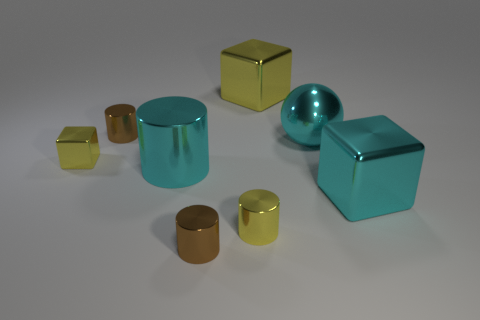How many other things are there of the same material as the large cyan ball?
Offer a terse response. 7. How many other yellow matte things are the same shape as the large yellow thing?
Your answer should be compact. 0. The large thing that is on the right side of the large cyan metal cylinder and in front of the big ball is what color?
Keep it short and to the point. Cyan. How many tiny yellow objects are there?
Your response must be concise. 2. Do the cyan block and the yellow metal cylinder have the same size?
Your answer should be very brief. No. Is there a big object of the same color as the sphere?
Make the answer very short. Yes. Do the cyan thing that is in front of the large cyan cylinder and the big yellow thing have the same shape?
Offer a very short reply. Yes. How many yellow cylinders have the same size as the cyan cylinder?
Provide a short and direct response. 0. How many large shiny cubes are in front of the small cylinder that is behind the cyan metal ball?
Make the answer very short. 1. Is the cylinder behind the large cyan metallic ball made of the same material as the large cyan sphere?
Offer a terse response. Yes. 